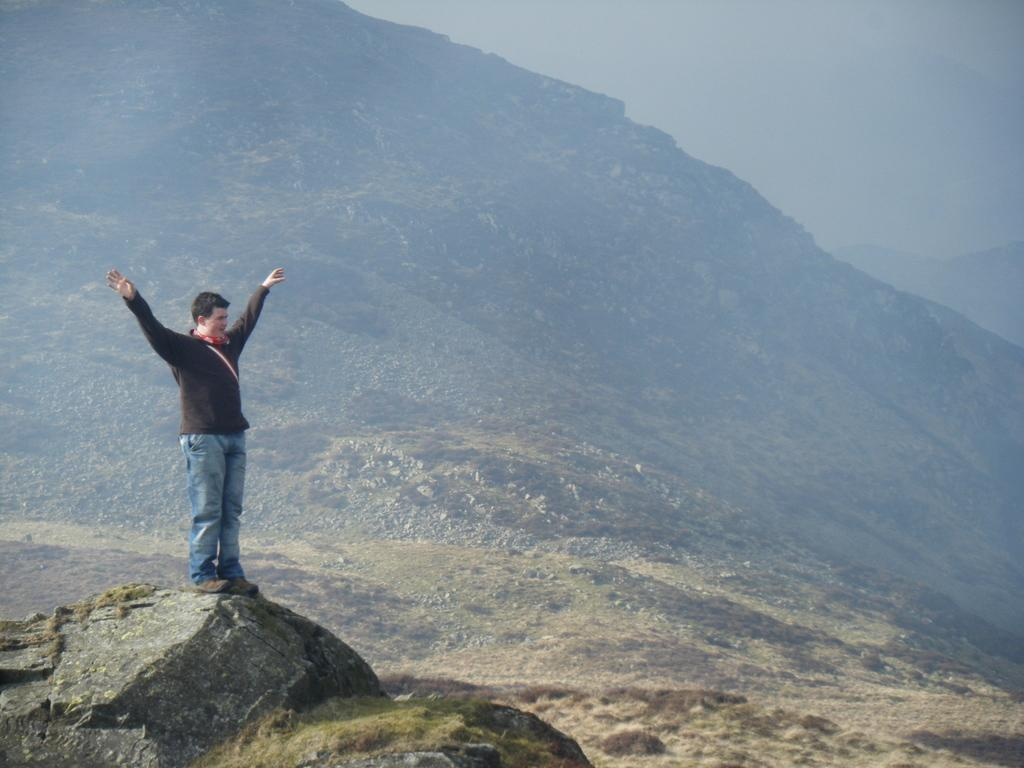What is the man in the image doing? The man is standing on a rock in the image. What other objects can be seen in the image? There are stones in the image. What can be seen in the background of the image? There is a mountain in the background of the image. How would you describe the sky in the image? The sky is clear and foggy in the image. Where is the nest of the grape-eating bird in the image? There is no nest or bird mentioned in the image; it only features a man standing on a rock, stones, a mountain, and a clear and foggy sky. 